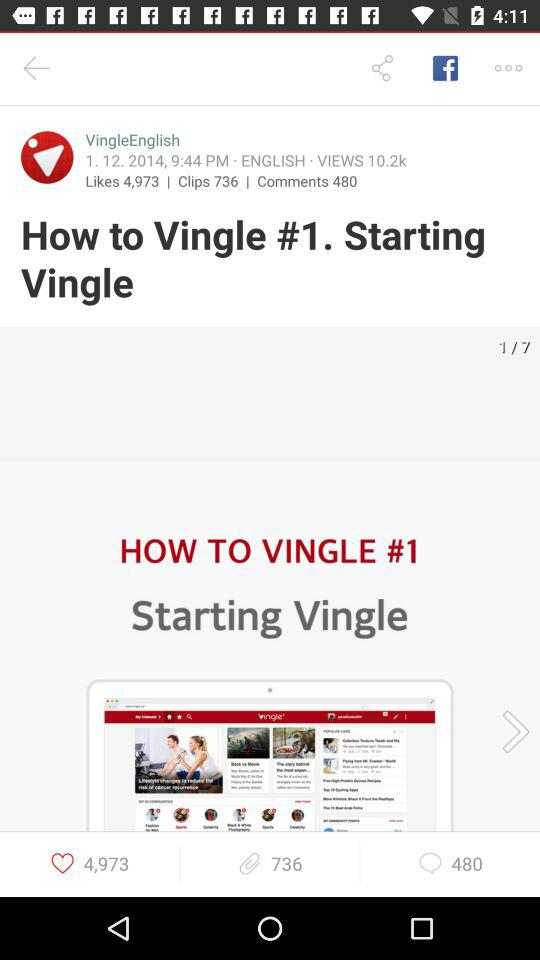On what date was the post posted by "VingleEnglish"? The post was posted by "VingleEnglish" on January 12, 2014. 